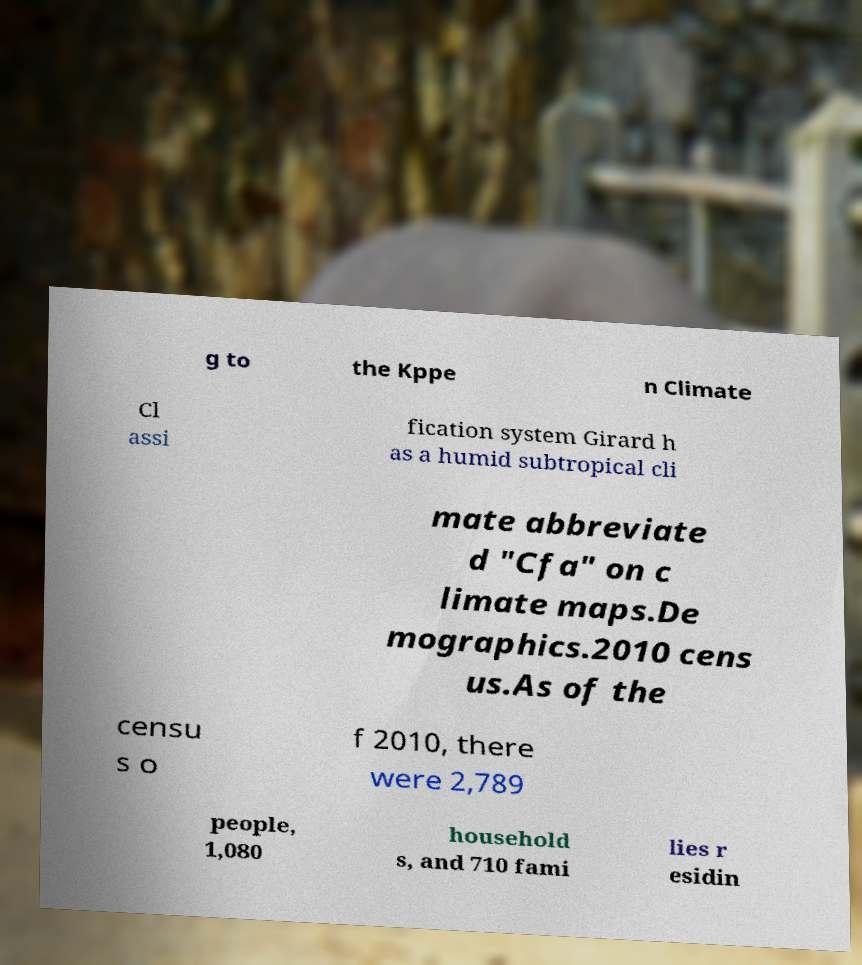For documentation purposes, I need the text within this image transcribed. Could you provide that? g to the Kppe n Climate Cl assi fication system Girard h as a humid subtropical cli mate abbreviate d "Cfa" on c limate maps.De mographics.2010 cens us.As of the censu s o f 2010, there were 2,789 people, 1,080 household s, and 710 fami lies r esidin 